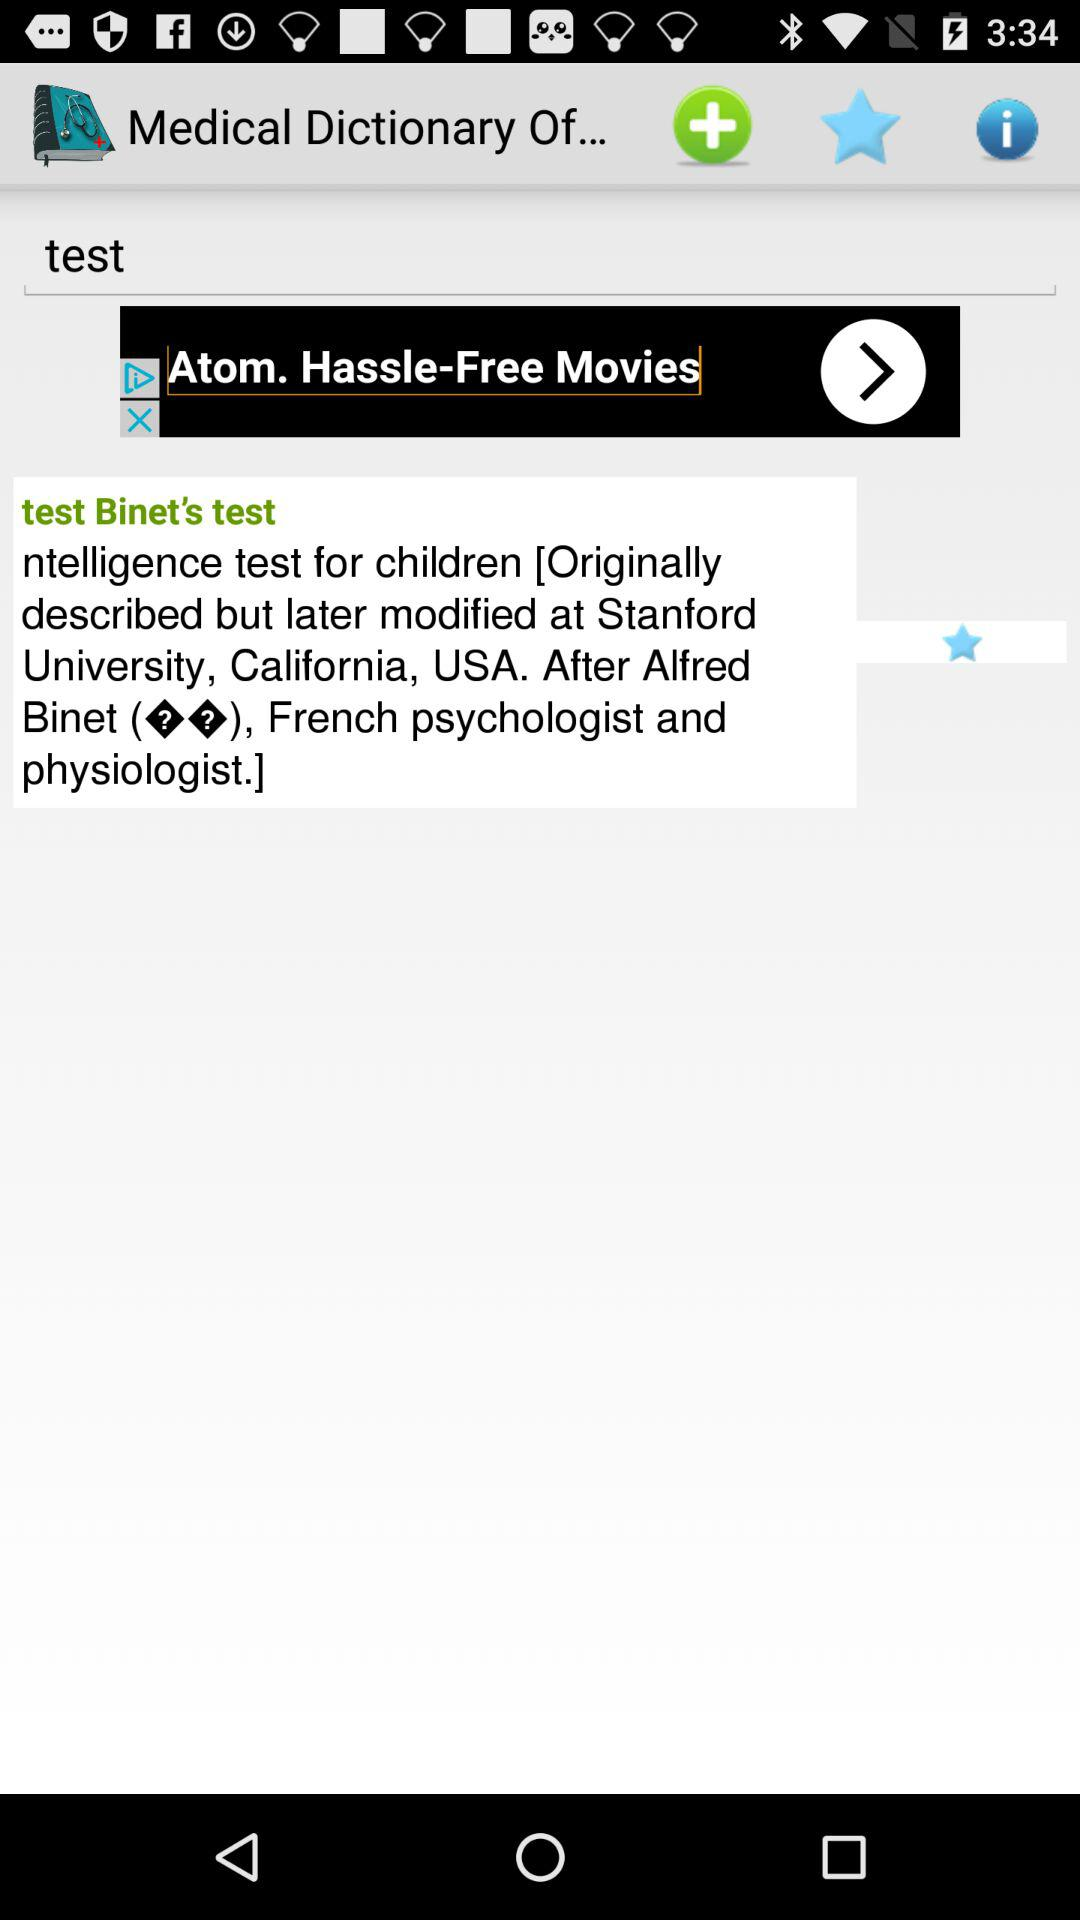What is the text entered in the text input field? The text entered in the text input field is "test". 